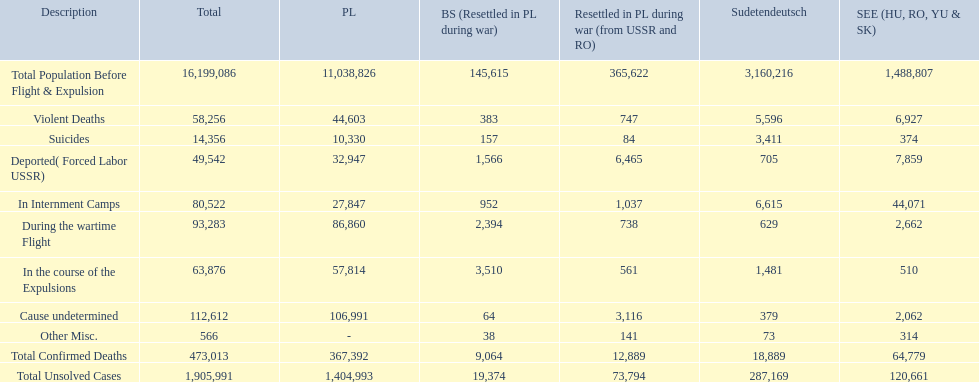What are the numbers of violent deaths across the area? 44,603, 383, 747, 5,596, 6,927. What is the total number of violent deaths of the area? 58,256. 